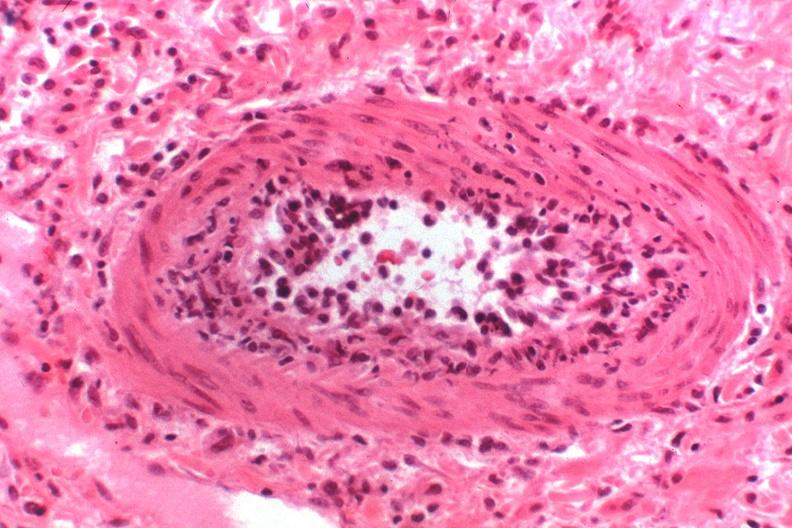where is this?
Answer the question using a single word or phrase. Urinary 